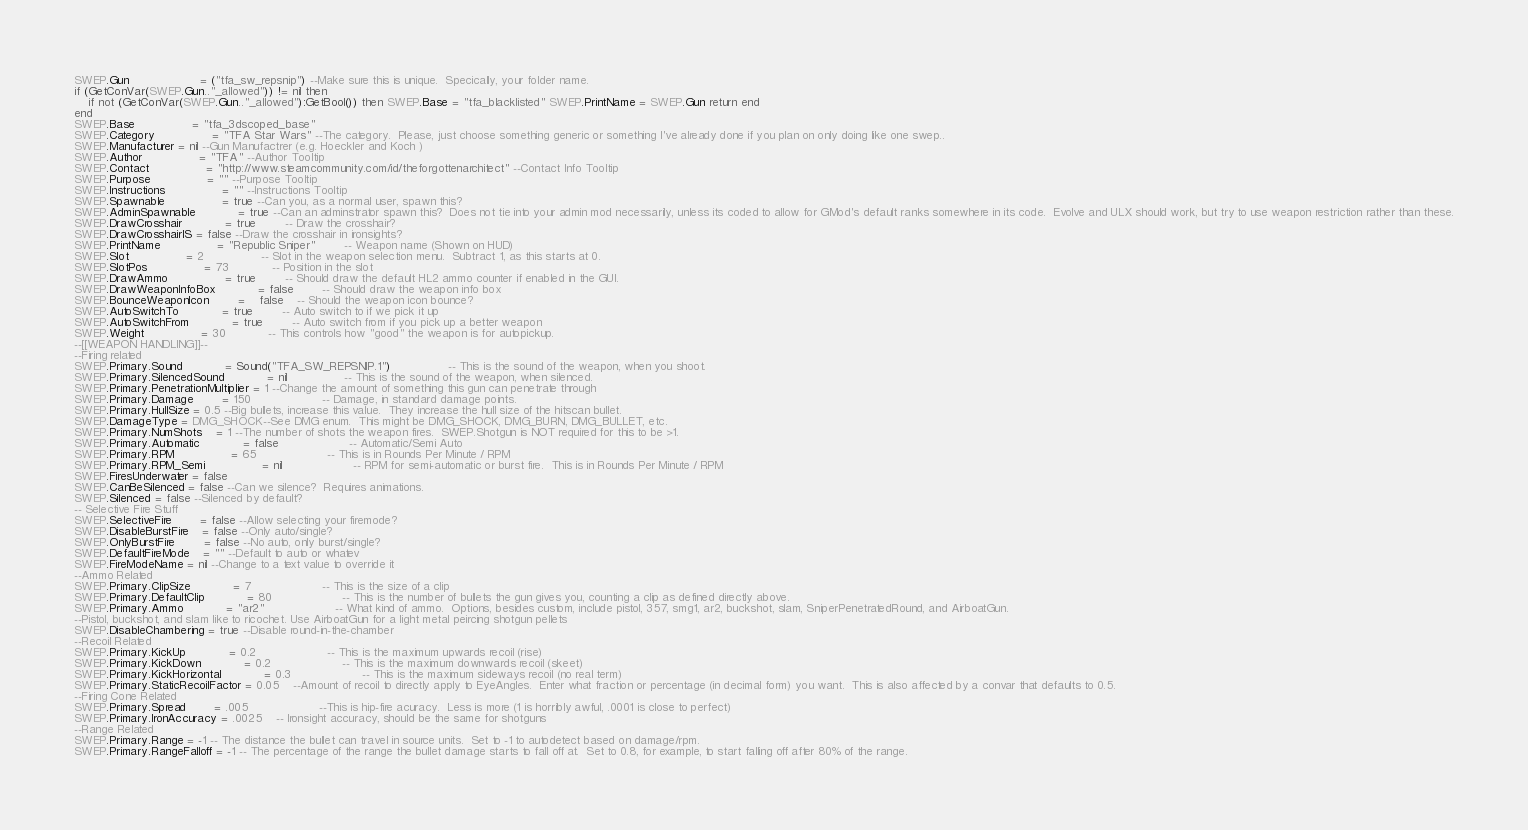Convert code to text. <code><loc_0><loc_0><loc_500><loc_500><_Lua_>SWEP.Gun					= ("tfa_sw_repsnip") --Make sure this is unique.  Specically, your folder name.  
if (GetConVar(SWEP.Gun.."_allowed")) != nil then
	if not (GetConVar(SWEP.Gun.."_allowed"):GetBool()) then SWEP.Base = "tfa_blacklisted" SWEP.PrintName = SWEP.Gun return end
end
SWEP.Base				= "tfa_3dscoped_base"
SWEP.Category				= "TFA Star Wars" --The category.  Please, just choose something generic or something I've already done if you plan on only doing like one swep..  
SWEP.Manufacturer = nil --Gun Manufactrer (e.g. Hoeckler and Koch )
SWEP.Author				= "TFA" --Author Tooltip
SWEP.Contact				= "http://www.steamcommunity.com/id/theforgottenarchitect" --Contact Info Tooltip
SWEP.Purpose				= "" --Purpose Tooltip
SWEP.Instructions				= "" --Instructions Tooltip
SWEP.Spawnable				= true --Can you, as a normal user, spawn this?
SWEP.AdminSpawnable			= true --Can an adminstrator spawn this?  Does not tie into your admin mod necessarily, unless its coded to allow for GMod's default ranks somewhere in its code.  Evolve and ULX should work, but try to use weapon restriction rather than these.
SWEP.DrawCrosshair			= true		-- Draw the crosshair?
SWEP.DrawCrosshairIS = false --Draw the crosshair in ironsights?
SWEP.PrintName				= "Republic Sniper"		-- Weapon name (Shown on HUD)	
SWEP.Slot				= 2				-- Slot in the weapon selection menu.  Subtract 1, as this starts at 0.
SWEP.SlotPos				= 73			-- Position in the slot
SWEP.DrawAmmo				= true		-- Should draw the default HL2 ammo counter if enabled in the GUI.
SWEP.DrawWeaponInfoBox			= false		-- Should draw the weapon info box
SWEP.BounceWeaponIcon   		= 	false	-- Should the weapon icon bounce?
SWEP.AutoSwitchTo			= true		-- Auto switch to if we pick it up
SWEP.AutoSwitchFrom			= true		-- Auto switch from if you pick up a better weapon
SWEP.Weight				= 30			-- This controls how "good" the weapon is for autopickup.
--[[WEAPON HANDLING]]--
--Firing related
SWEP.Primary.Sound 			= Sound("TFA_SW_REPSNIP.1")				-- This is the sound of the weapon, when you shoot.
SWEP.Primary.SilencedSound 			= nil				-- This is the sound of the weapon, when silenced.
SWEP.Primary.PenetrationMultiplier = 1 --Change the amount of something this gun can penetrate through
SWEP.Primary.Damage		= 150					-- Damage, in standard damage points.
SWEP.Primary.HullSize = 0.5 --Big bullets, increase this value.  They increase the hull size of the hitscan bullet.
SWEP.DamageType = DMG_SHOCK--See DMG enum.  This might be DMG_SHOCK, DMG_BURN, DMG_BULLET, etc.
SWEP.Primary.NumShots	= 1 --The number of shots the weapon fires.  SWEP.Shotgun is NOT required for this to be >1.
SWEP.Primary.Automatic			= false					-- Automatic/Semi Auto
SWEP.Primary.RPM				= 65					-- This is in Rounds Per Minute / RPM
SWEP.Primary.RPM_Semi				= nil					-- RPM for semi-automatic or burst fire.  This is in Rounds Per Minute / RPM
SWEP.FiresUnderwater = false
SWEP.CanBeSilenced = false --Can we silence?  Requires animations.
SWEP.Silenced = false --Silenced by default?
-- Selective Fire Stuff
SWEP.SelectiveFire		= false --Allow selecting your firemode?
SWEP.DisableBurstFire	= false --Only auto/single?
SWEP.OnlyBurstFire		= false --No auto, only burst/single?
SWEP.DefaultFireMode 	= "" --Default to auto or whatev
SWEP.FireModeName = nil --Change to a text value to override it
--Ammo Related
SWEP.Primary.ClipSize			= 7					-- This is the size of a clip
SWEP.Primary.DefaultClip			= 80					-- This is the number of bullets the gun gives you, counting a clip as defined directly above.
SWEP.Primary.Ammo			= "ar2"					-- What kind of ammo.  Options, besides custom, include pistol, 357, smg1, ar2, buckshot, slam, SniperPenetratedRound, and AirboatGun.  
--Pistol, buckshot, and slam like to ricochet. Use AirboatGun for a light metal peircing shotgun pellets
SWEP.DisableChambering = true --Disable round-in-the-chamber
--Recoil Related
SWEP.Primary.KickUp			= 0.2					-- This is the maximum upwards recoil (rise)
SWEP.Primary.KickDown			= 0.2					-- This is the maximum downwards recoil (skeet)
SWEP.Primary.KickHorizontal			= 0.3					-- This is the maximum sideways recoil (no real term)
SWEP.Primary.StaticRecoilFactor = 0.05 	--Amount of recoil to directly apply to EyeAngles.  Enter what fraction or percentage (in decimal form) you want.  This is also affected by a convar that defaults to 0.5.
--Firing Cone Related
SWEP.Primary.Spread		= .005					--This is hip-fire acuracy.  Less is more (1 is horribly awful, .0001 is close to perfect)
SWEP.Primary.IronAccuracy = .0025	-- Ironsight accuracy, should be the same for shotguns
--Range Related
SWEP.Primary.Range = -1 -- The distance the bullet can travel in source units.  Set to -1 to autodetect based on damage/rpm.
SWEP.Primary.RangeFalloff = -1 -- The percentage of the range the bullet damage starts to fall off at.  Set to 0.8, for example, to start falling off after 80% of the range.</code> 